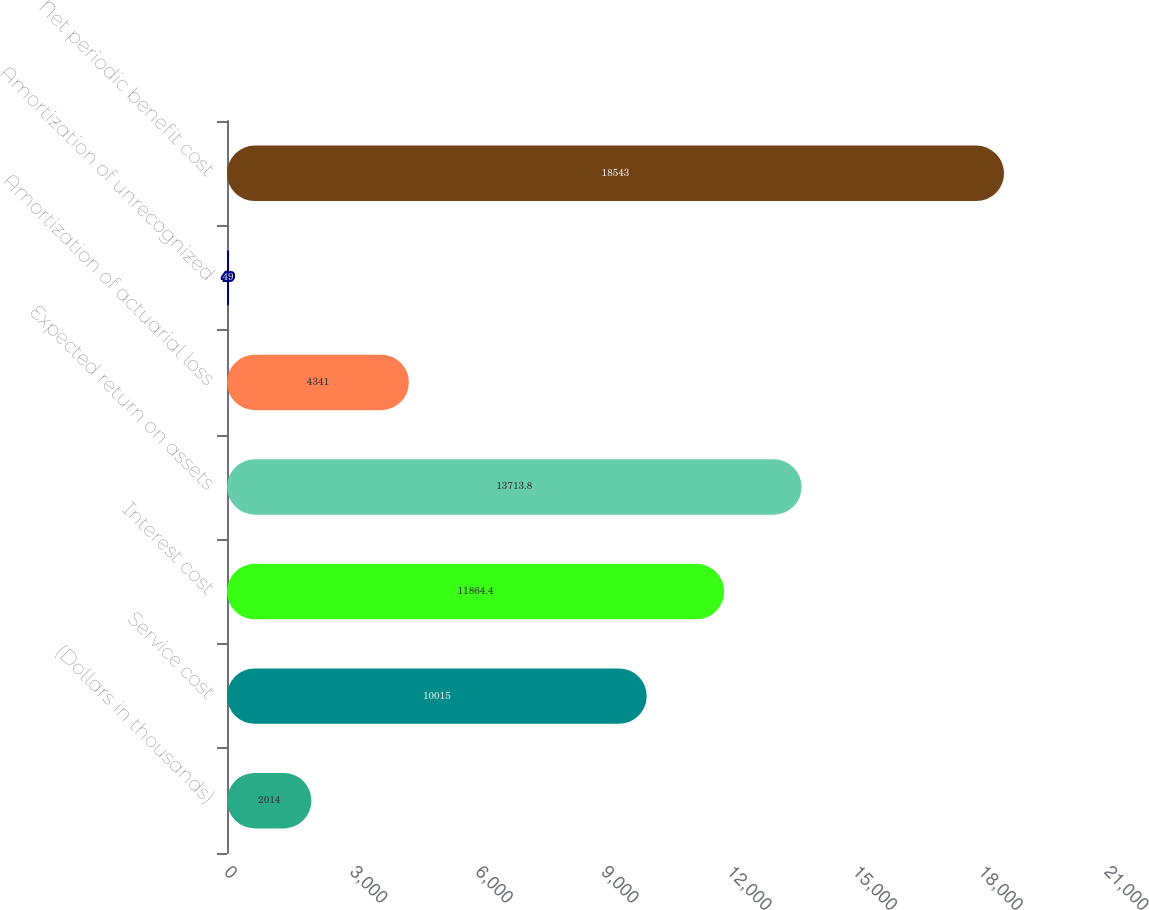Convert chart to OTSL. <chart><loc_0><loc_0><loc_500><loc_500><bar_chart><fcel>(Dollars in thousands)<fcel>Service cost<fcel>Interest cost<fcel>Expected return on assets<fcel>Amortization of actuarial loss<fcel>Amortization of unrecognized<fcel>Net periodic benefit cost<nl><fcel>2014<fcel>10015<fcel>11864.4<fcel>13713.8<fcel>4341<fcel>49<fcel>18543<nl></chart> 